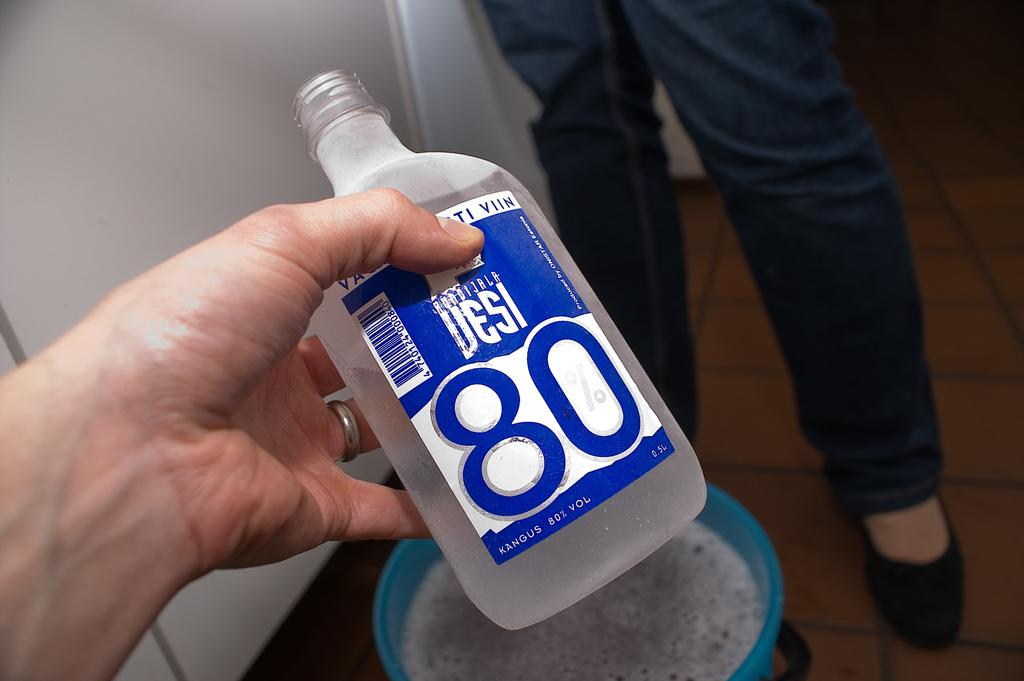<image>
Relay a brief, clear account of the picture shown. A bottle of Desi 80 in someones hand with another person. 